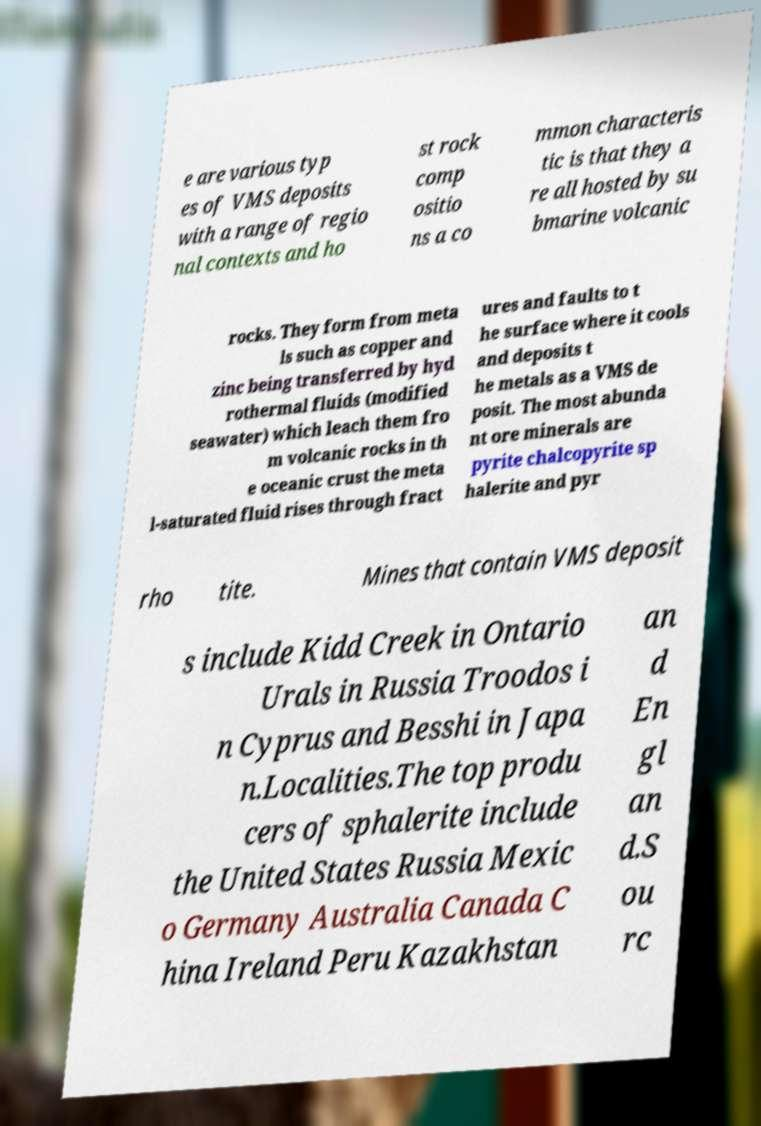Can you read and provide the text displayed in the image?This photo seems to have some interesting text. Can you extract and type it out for me? e are various typ es of VMS deposits with a range of regio nal contexts and ho st rock comp ositio ns a co mmon characteris tic is that they a re all hosted by su bmarine volcanic rocks. They form from meta ls such as copper and zinc being transferred by hyd rothermal fluids (modified seawater) which leach them fro m volcanic rocks in th e oceanic crust the meta l-saturated fluid rises through fract ures and faults to t he surface where it cools and deposits t he metals as a VMS de posit. The most abunda nt ore minerals are pyrite chalcopyrite sp halerite and pyr rho tite. Mines that contain VMS deposit s include Kidd Creek in Ontario Urals in Russia Troodos i n Cyprus and Besshi in Japa n.Localities.The top produ cers of sphalerite include the United States Russia Mexic o Germany Australia Canada C hina Ireland Peru Kazakhstan an d En gl an d.S ou rc 